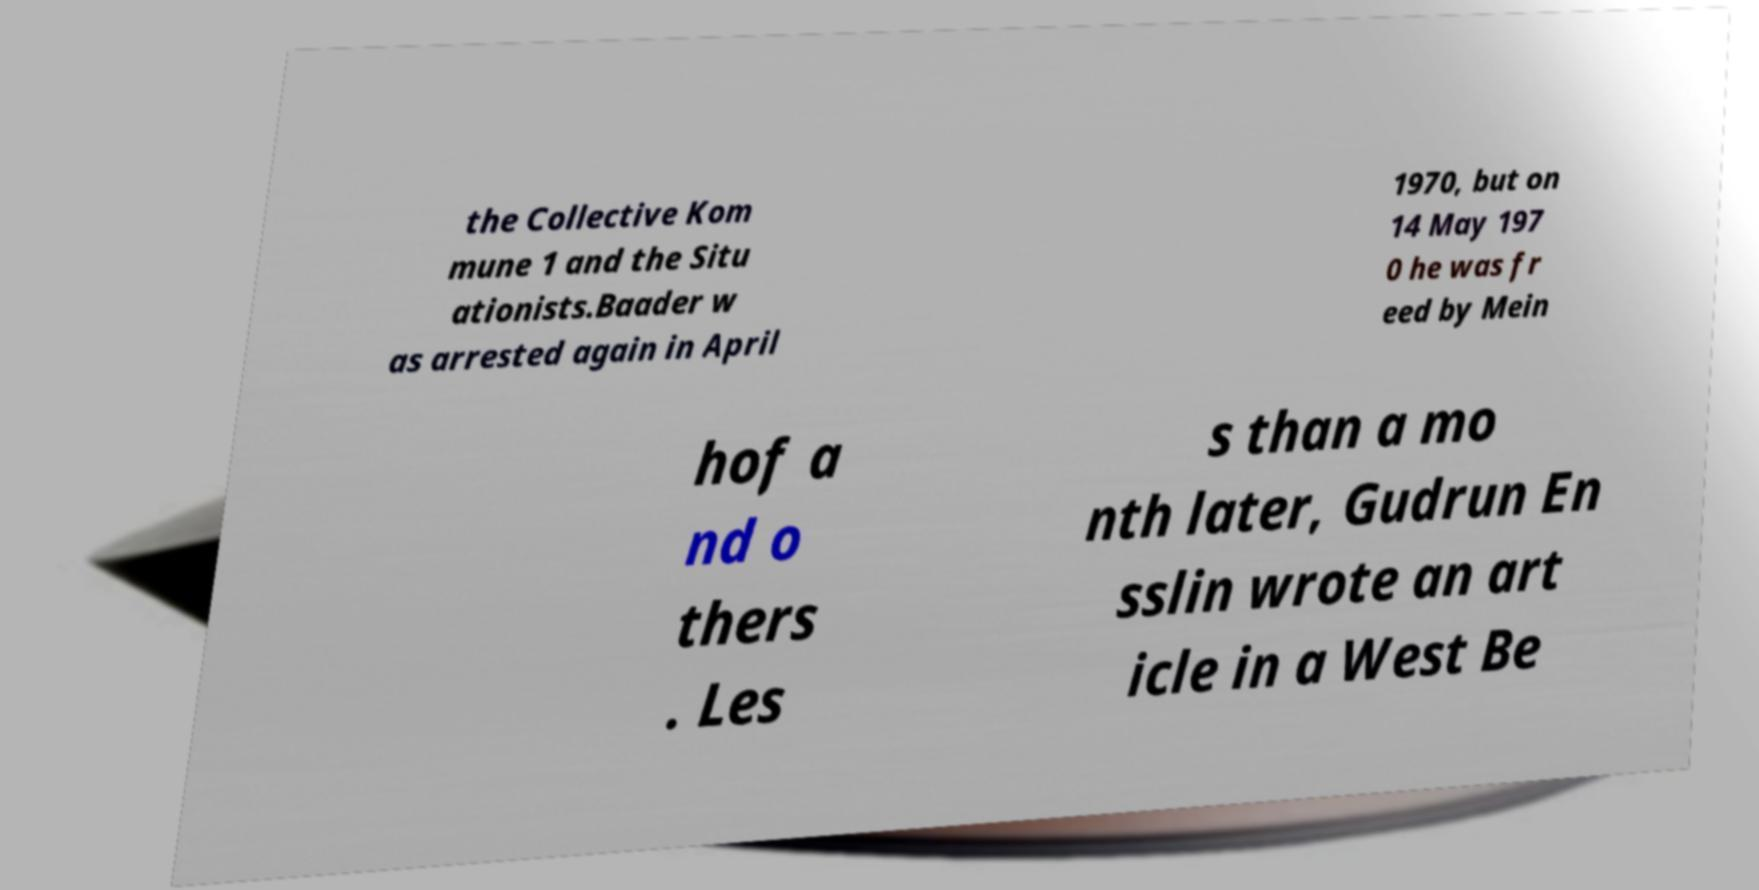Can you accurately transcribe the text from the provided image for me? the Collective Kom mune 1 and the Situ ationists.Baader w as arrested again in April 1970, but on 14 May 197 0 he was fr eed by Mein hof a nd o thers . Les s than a mo nth later, Gudrun En sslin wrote an art icle in a West Be 